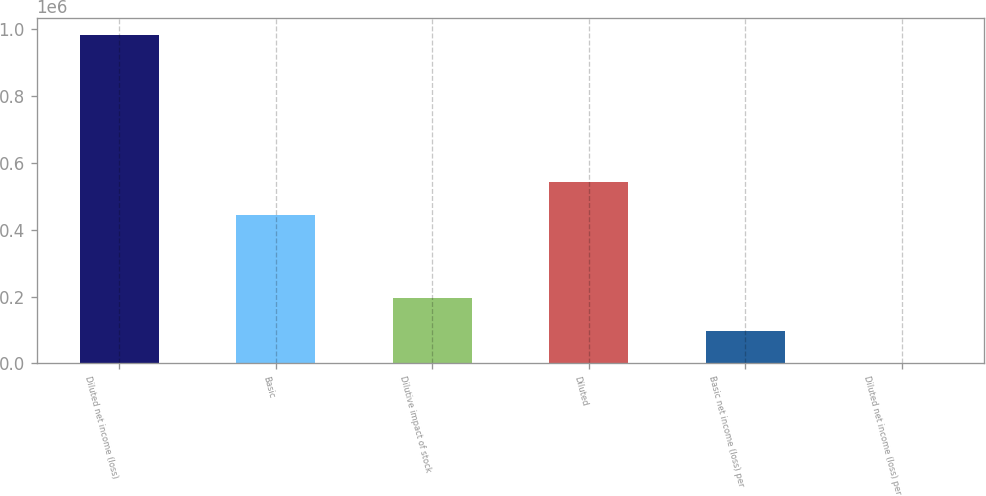Convert chart. <chart><loc_0><loc_0><loc_500><loc_500><bar_chart><fcel>Diluted net income (loss)<fcel>Basic<fcel>Dilutive impact of stock<fcel>Diluted<fcel>Basic net income (loss) per<fcel>Diluted net income (loss) per<nl><fcel>984729<fcel>445865<fcel>196948<fcel>544338<fcel>98474.9<fcel>2.2<nl></chart> 